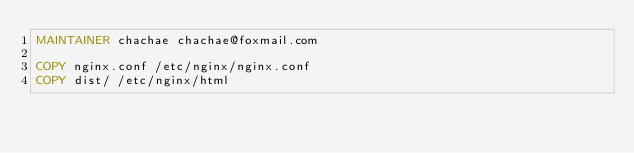<code> <loc_0><loc_0><loc_500><loc_500><_Dockerfile_>MAINTAINER chachae chachae@foxmail.com

COPY nginx.conf /etc/nginx/nginx.conf
COPY dist/ /etc/nginx/html
</code> 